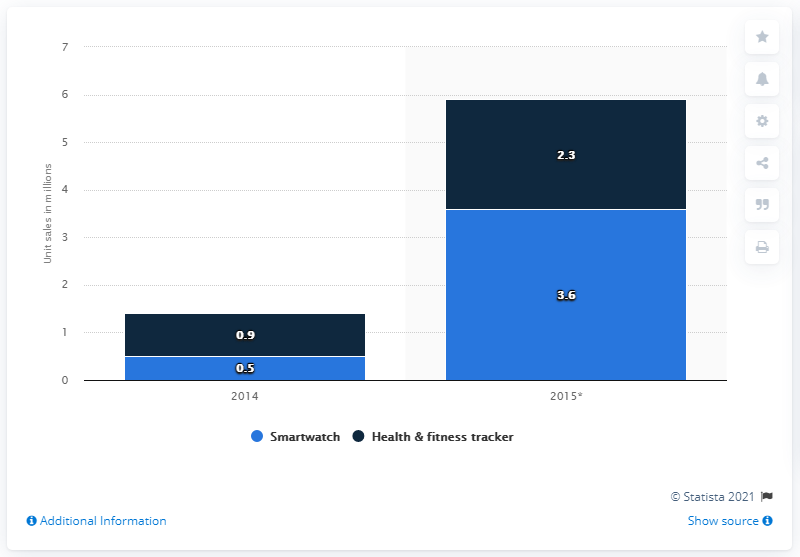Give some essential details in this illustration. It is predicted that 3.6 units of smartwatches will be sold in China in 2015. 